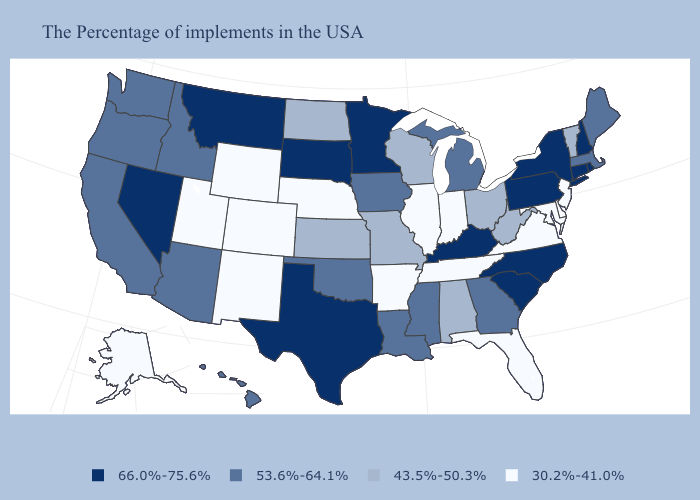Which states hav the highest value in the Northeast?
Quick response, please. Rhode Island, New Hampshire, Connecticut, New York, Pennsylvania. What is the lowest value in the USA?
Be succinct. 30.2%-41.0%. What is the lowest value in the Northeast?
Short answer required. 30.2%-41.0%. Does Minnesota have the highest value in the USA?
Be succinct. Yes. Does New Jersey have the lowest value in the Northeast?
Answer briefly. Yes. What is the value of New Mexico?
Write a very short answer. 30.2%-41.0%. What is the value of Indiana?
Answer briefly. 30.2%-41.0%. How many symbols are there in the legend?
Short answer required. 4. What is the value of Mississippi?
Short answer required. 53.6%-64.1%. Does Oregon have the lowest value in the USA?
Be succinct. No. Does Connecticut have the highest value in the USA?
Answer briefly. Yes. What is the lowest value in the USA?
Quick response, please. 30.2%-41.0%. Which states have the highest value in the USA?
Be succinct. Rhode Island, New Hampshire, Connecticut, New York, Pennsylvania, North Carolina, South Carolina, Kentucky, Minnesota, Texas, South Dakota, Montana, Nevada. How many symbols are there in the legend?
Short answer required. 4. 